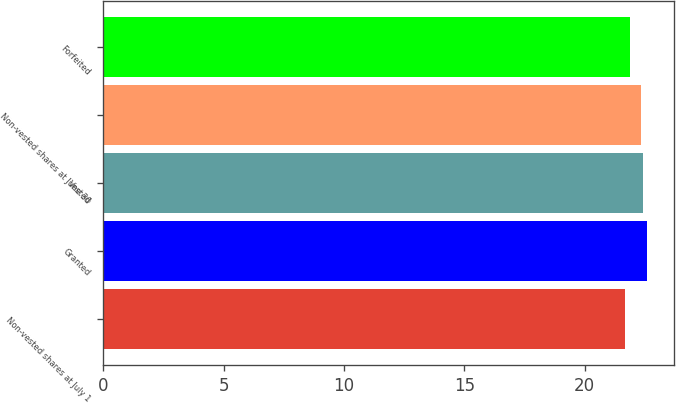<chart> <loc_0><loc_0><loc_500><loc_500><bar_chart><fcel>Non-vested shares at July 1<fcel>Granted<fcel>Vested<fcel>Non-vested shares at June 30<fcel>Forfeited<nl><fcel>21.66<fcel>22.59<fcel>22.43<fcel>22.34<fcel>21.88<nl></chart> 